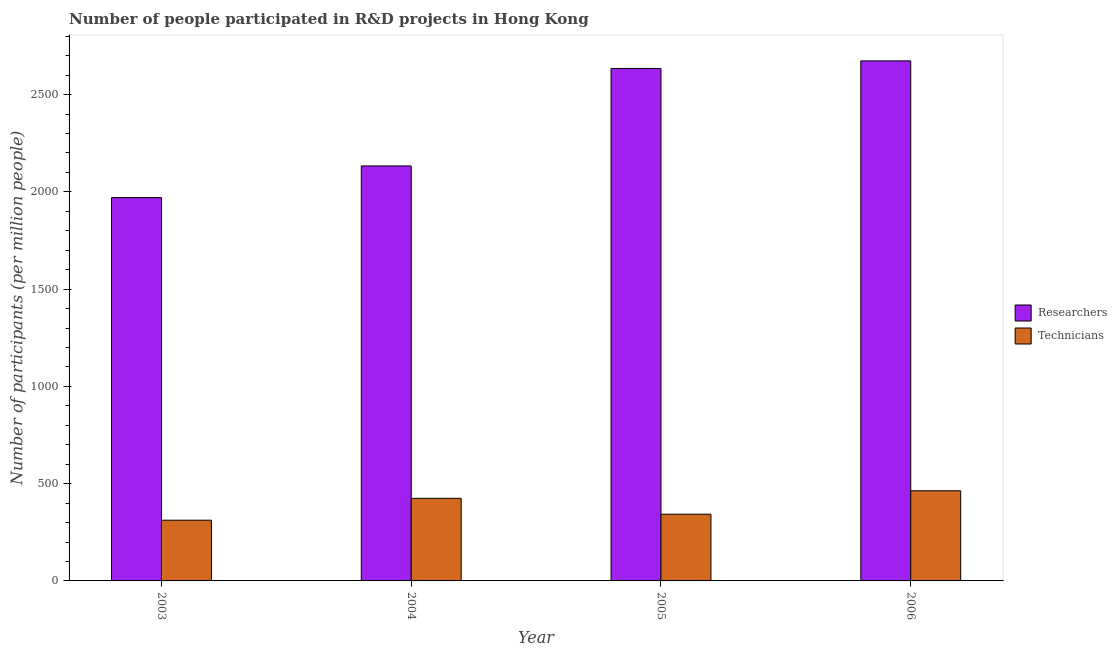How many different coloured bars are there?
Your answer should be compact. 2. How many groups of bars are there?
Make the answer very short. 4. Are the number of bars on each tick of the X-axis equal?
Make the answer very short. Yes. How many bars are there on the 4th tick from the left?
Your answer should be compact. 2. What is the number of researchers in 2003?
Ensure brevity in your answer.  1970.26. Across all years, what is the maximum number of technicians?
Keep it short and to the point. 463.26. Across all years, what is the minimum number of technicians?
Offer a very short reply. 312.1. In which year was the number of technicians minimum?
Your answer should be compact. 2003. What is the total number of technicians in the graph?
Keep it short and to the point. 1542.67. What is the difference between the number of researchers in 2003 and that in 2004?
Offer a very short reply. -162.83. What is the difference between the number of researchers in 2005 and the number of technicians in 2006?
Offer a terse response. -38.92. What is the average number of technicians per year?
Offer a terse response. 385.67. In the year 2004, what is the difference between the number of researchers and number of technicians?
Give a very brief answer. 0. What is the ratio of the number of researchers in 2004 to that in 2006?
Give a very brief answer. 0.8. What is the difference between the highest and the second highest number of researchers?
Make the answer very short. 38.92. What is the difference between the highest and the lowest number of technicians?
Ensure brevity in your answer.  151.16. Is the sum of the number of researchers in 2004 and 2006 greater than the maximum number of technicians across all years?
Keep it short and to the point. Yes. What does the 2nd bar from the left in 2005 represents?
Give a very brief answer. Technicians. What does the 1st bar from the right in 2006 represents?
Provide a succinct answer. Technicians. How many bars are there?
Make the answer very short. 8. How many years are there in the graph?
Keep it short and to the point. 4. What is the difference between two consecutive major ticks on the Y-axis?
Make the answer very short. 500. Does the graph contain any zero values?
Ensure brevity in your answer.  No. Where does the legend appear in the graph?
Make the answer very short. Center right. How many legend labels are there?
Your answer should be compact. 2. What is the title of the graph?
Provide a short and direct response. Number of people participated in R&D projects in Hong Kong. Does "Attending school" appear as one of the legend labels in the graph?
Offer a very short reply. No. What is the label or title of the X-axis?
Offer a very short reply. Year. What is the label or title of the Y-axis?
Make the answer very short. Number of participants (per million people). What is the Number of participants (per million people) in Researchers in 2003?
Ensure brevity in your answer.  1970.26. What is the Number of participants (per million people) of Technicians in 2003?
Make the answer very short. 312.1. What is the Number of participants (per million people) of Researchers in 2004?
Your answer should be compact. 2133.09. What is the Number of participants (per million people) in Technicians in 2004?
Offer a very short reply. 424.46. What is the Number of participants (per million people) of Researchers in 2005?
Offer a very short reply. 2634.14. What is the Number of participants (per million people) of Technicians in 2005?
Ensure brevity in your answer.  342.86. What is the Number of participants (per million people) in Researchers in 2006?
Ensure brevity in your answer.  2673.06. What is the Number of participants (per million people) in Technicians in 2006?
Give a very brief answer. 463.26. Across all years, what is the maximum Number of participants (per million people) in Researchers?
Offer a very short reply. 2673.06. Across all years, what is the maximum Number of participants (per million people) of Technicians?
Your response must be concise. 463.26. Across all years, what is the minimum Number of participants (per million people) in Researchers?
Offer a terse response. 1970.26. Across all years, what is the minimum Number of participants (per million people) in Technicians?
Offer a terse response. 312.1. What is the total Number of participants (per million people) of Researchers in the graph?
Your answer should be compact. 9410.55. What is the total Number of participants (per million people) in Technicians in the graph?
Offer a terse response. 1542.67. What is the difference between the Number of participants (per million people) of Researchers in 2003 and that in 2004?
Keep it short and to the point. -162.83. What is the difference between the Number of participants (per million people) of Technicians in 2003 and that in 2004?
Your response must be concise. -112.36. What is the difference between the Number of participants (per million people) of Researchers in 2003 and that in 2005?
Your response must be concise. -663.88. What is the difference between the Number of participants (per million people) of Technicians in 2003 and that in 2005?
Make the answer very short. -30.76. What is the difference between the Number of participants (per million people) in Researchers in 2003 and that in 2006?
Provide a short and direct response. -702.8. What is the difference between the Number of participants (per million people) of Technicians in 2003 and that in 2006?
Your answer should be compact. -151.16. What is the difference between the Number of participants (per million people) of Researchers in 2004 and that in 2005?
Your answer should be very brief. -501.04. What is the difference between the Number of participants (per million people) in Technicians in 2004 and that in 2005?
Make the answer very short. 81.6. What is the difference between the Number of participants (per million people) in Researchers in 2004 and that in 2006?
Your response must be concise. -539.96. What is the difference between the Number of participants (per million people) in Technicians in 2004 and that in 2006?
Provide a succinct answer. -38.8. What is the difference between the Number of participants (per million people) of Researchers in 2005 and that in 2006?
Offer a very short reply. -38.92. What is the difference between the Number of participants (per million people) in Technicians in 2005 and that in 2006?
Your response must be concise. -120.4. What is the difference between the Number of participants (per million people) in Researchers in 2003 and the Number of participants (per million people) in Technicians in 2004?
Ensure brevity in your answer.  1545.81. What is the difference between the Number of participants (per million people) in Researchers in 2003 and the Number of participants (per million people) in Technicians in 2005?
Your response must be concise. 1627.4. What is the difference between the Number of participants (per million people) of Researchers in 2003 and the Number of participants (per million people) of Technicians in 2006?
Offer a very short reply. 1507.01. What is the difference between the Number of participants (per million people) in Researchers in 2004 and the Number of participants (per million people) in Technicians in 2005?
Keep it short and to the point. 1790.24. What is the difference between the Number of participants (per million people) of Researchers in 2004 and the Number of participants (per million people) of Technicians in 2006?
Your answer should be very brief. 1669.84. What is the difference between the Number of participants (per million people) in Researchers in 2005 and the Number of participants (per million people) in Technicians in 2006?
Keep it short and to the point. 2170.88. What is the average Number of participants (per million people) of Researchers per year?
Keep it short and to the point. 2352.64. What is the average Number of participants (per million people) in Technicians per year?
Offer a very short reply. 385.67. In the year 2003, what is the difference between the Number of participants (per million people) of Researchers and Number of participants (per million people) of Technicians?
Your answer should be very brief. 1658.16. In the year 2004, what is the difference between the Number of participants (per million people) in Researchers and Number of participants (per million people) in Technicians?
Give a very brief answer. 1708.64. In the year 2005, what is the difference between the Number of participants (per million people) in Researchers and Number of participants (per million people) in Technicians?
Provide a succinct answer. 2291.28. In the year 2006, what is the difference between the Number of participants (per million people) of Researchers and Number of participants (per million people) of Technicians?
Keep it short and to the point. 2209.8. What is the ratio of the Number of participants (per million people) in Researchers in 2003 to that in 2004?
Provide a short and direct response. 0.92. What is the ratio of the Number of participants (per million people) in Technicians in 2003 to that in 2004?
Your response must be concise. 0.74. What is the ratio of the Number of participants (per million people) in Researchers in 2003 to that in 2005?
Your response must be concise. 0.75. What is the ratio of the Number of participants (per million people) in Technicians in 2003 to that in 2005?
Offer a very short reply. 0.91. What is the ratio of the Number of participants (per million people) of Researchers in 2003 to that in 2006?
Offer a terse response. 0.74. What is the ratio of the Number of participants (per million people) in Technicians in 2003 to that in 2006?
Offer a very short reply. 0.67. What is the ratio of the Number of participants (per million people) of Researchers in 2004 to that in 2005?
Keep it short and to the point. 0.81. What is the ratio of the Number of participants (per million people) in Technicians in 2004 to that in 2005?
Your response must be concise. 1.24. What is the ratio of the Number of participants (per million people) in Researchers in 2004 to that in 2006?
Keep it short and to the point. 0.8. What is the ratio of the Number of participants (per million people) of Technicians in 2004 to that in 2006?
Make the answer very short. 0.92. What is the ratio of the Number of participants (per million people) in Researchers in 2005 to that in 2006?
Your answer should be compact. 0.99. What is the ratio of the Number of participants (per million people) of Technicians in 2005 to that in 2006?
Your answer should be very brief. 0.74. What is the difference between the highest and the second highest Number of participants (per million people) in Researchers?
Give a very brief answer. 38.92. What is the difference between the highest and the second highest Number of participants (per million people) of Technicians?
Your response must be concise. 38.8. What is the difference between the highest and the lowest Number of participants (per million people) of Researchers?
Keep it short and to the point. 702.8. What is the difference between the highest and the lowest Number of participants (per million people) of Technicians?
Keep it short and to the point. 151.16. 